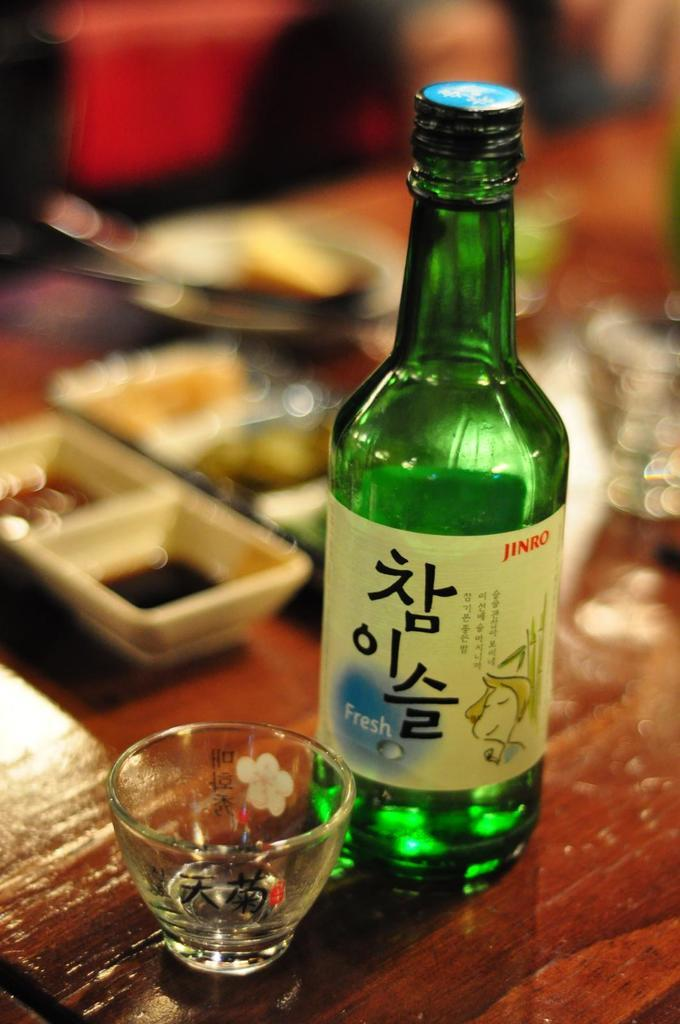<image>
Render a clear and concise summary of the photo. A beer Jinro beer with the word fresh next to Chinese writing. 